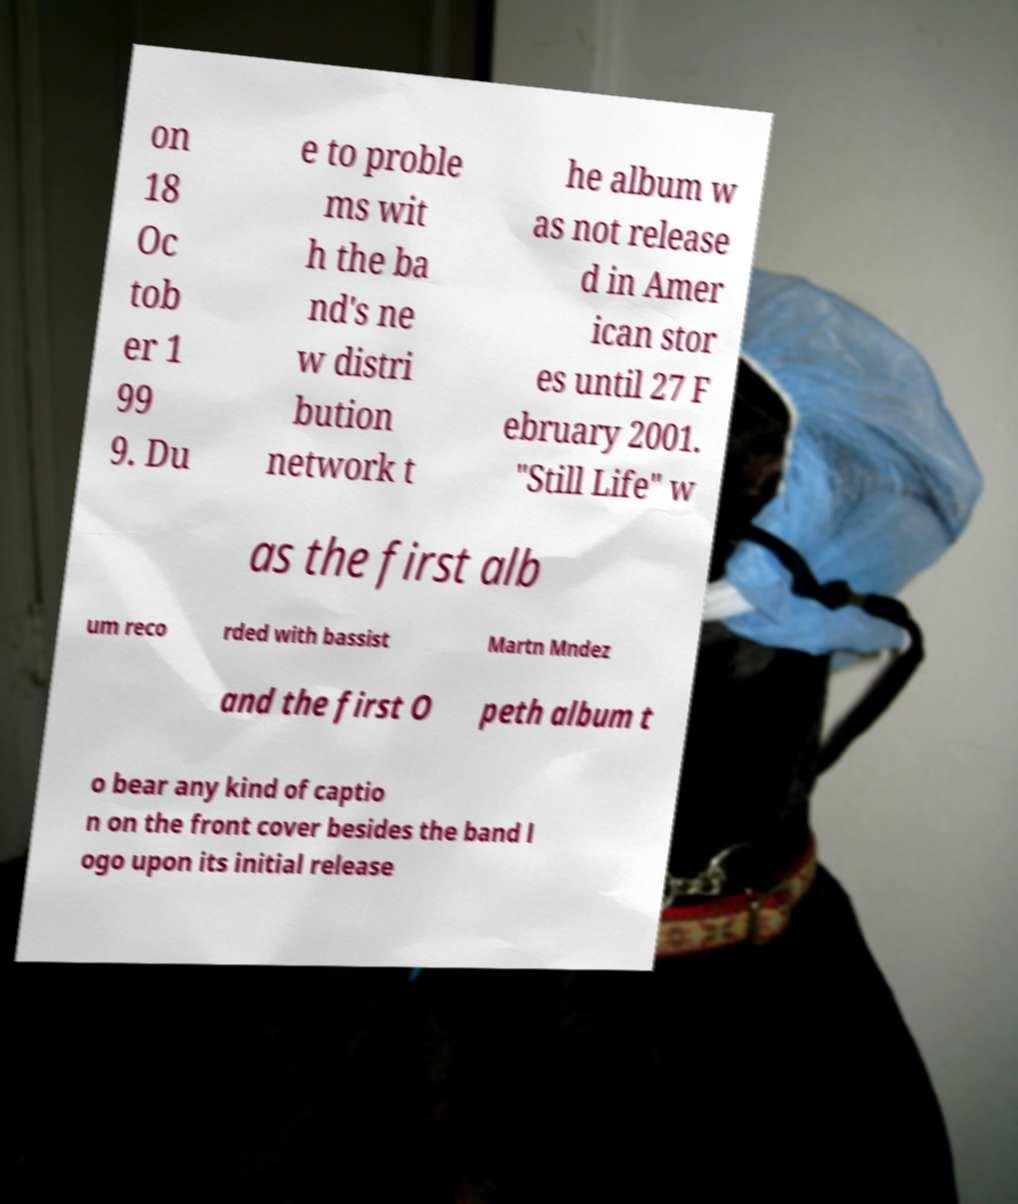Can you accurately transcribe the text from the provided image for me? on 18 Oc tob er 1 99 9. Du e to proble ms wit h the ba nd's ne w distri bution network t he album w as not release d in Amer ican stor es until 27 F ebruary 2001. "Still Life" w as the first alb um reco rded with bassist Martn Mndez and the first O peth album t o bear any kind of captio n on the front cover besides the band l ogo upon its initial release 